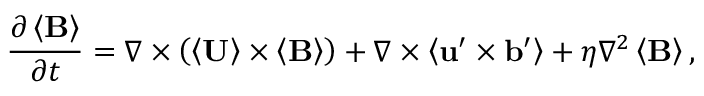Convert formula to latex. <formula><loc_0><loc_0><loc_500><loc_500>\frac { \partial \left \langle B \right \rangle } { \partial t } = \nabla \times \left ( \left \langle U \right \rangle \times \left \langle B \right \rangle \right ) + \nabla \times \left \langle u ^ { \prime } \times b ^ { \prime } \right \rangle + \eta \nabla ^ { 2 } \left \langle B \right \rangle ,</formula> 